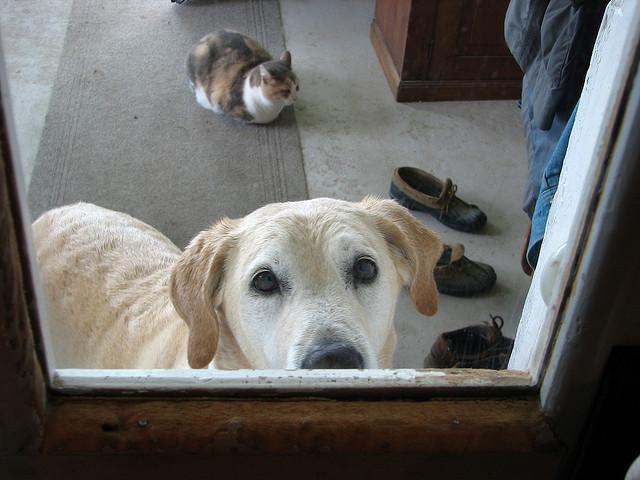How many animals are in this photo?
Give a very brief answer. 2. 